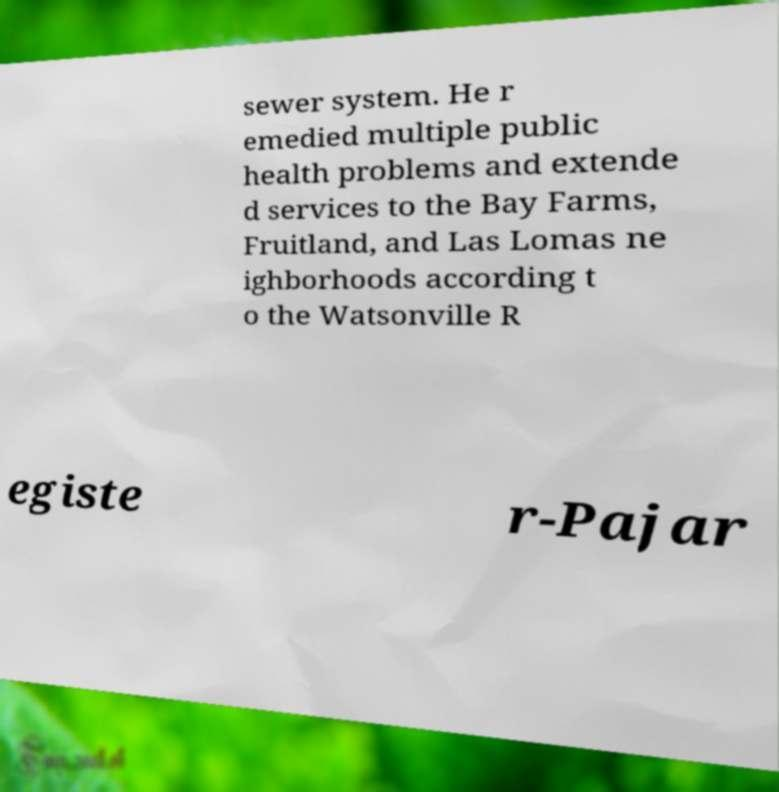What messages or text are displayed in this image? I need them in a readable, typed format. sewer system. He r emedied multiple public health problems and extende d services to the Bay Farms, Fruitland, and Las Lomas ne ighborhoods according t o the Watsonville R egiste r-Pajar 